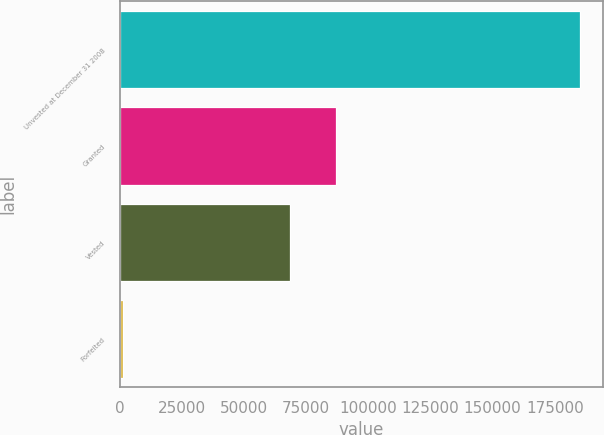Convert chart. <chart><loc_0><loc_0><loc_500><loc_500><bar_chart><fcel>Unvested at December 31 2008<fcel>Granted<fcel>Vested<fcel>Forfeited<nl><fcel>185291<fcel>86837.6<fcel>68458<fcel>1495<nl></chart> 